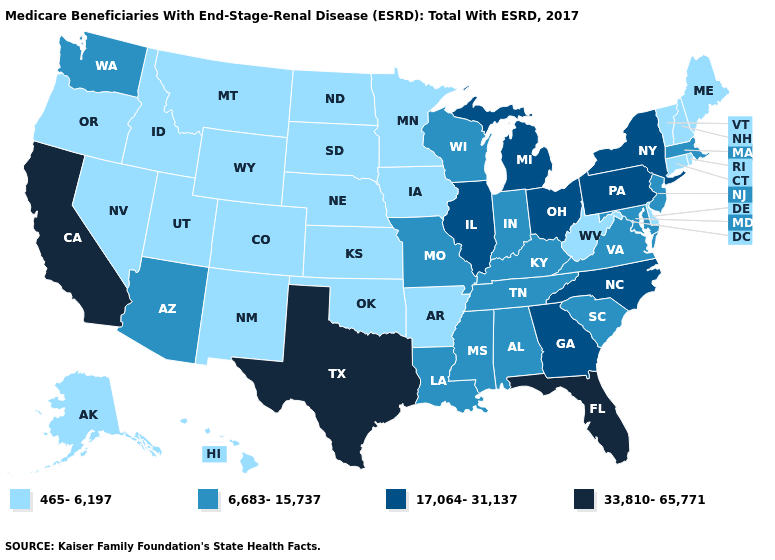Does Minnesota have a lower value than Tennessee?
Concise answer only. Yes. What is the value of Illinois?
Be succinct. 17,064-31,137. What is the highest value in the Northeast ?
Be succinct. 17,064-31,137. How many symbols are there in the legend?
Be succinct. 4. Name the states that have a value in the range 17,064-31,137?
Quick response, please. Georgia, Illinois, Michigan, New York, North Carolina, Ohio, Pennsylvania. What is the highest value in states that border Colorado?
Short answer required. 6,683-15,737. Among the states that border New York , which have the lowest value?
Short answer required. Connecticut, Vermont. Name the states that have a value in the range 465-6,197?
Concise answer only. Alaska, Arkansas, Colorado, Connecticut, Delaware, Hawaii, Idaho, Iowa, Kansas, Maine, Minnesota, Montana, Nebraska, Nevada, New Hampshire, New Mexico, North Dakota, Oklahoma, Oregon, Rhode Island, South Dakota, Utah, Vermont, West Virginia, Wyoming. What is the lowest value in states that border Indiana?
Write a very short answer. 6,683-15,737. Name the states that have a value in the range 33,810-65,771?
Concise answer only. California, Florida, Texas. Does Oregon have the lowest value in the West?
Answer briefly. Yes. Name the states that have a value in the range 17,064-31,137?
Short answer required. Georgia, Illinois, Michigan, New York, North Carolina, Ohio, Pennsylvania. How many symbols are there in the legend?
Answer briefly. 4. Does Virginia have the lowest value in the USA?
Concise answer only. No. Does Massachusetts have the lowest value in the Northeast?
Concise answer only. No. 